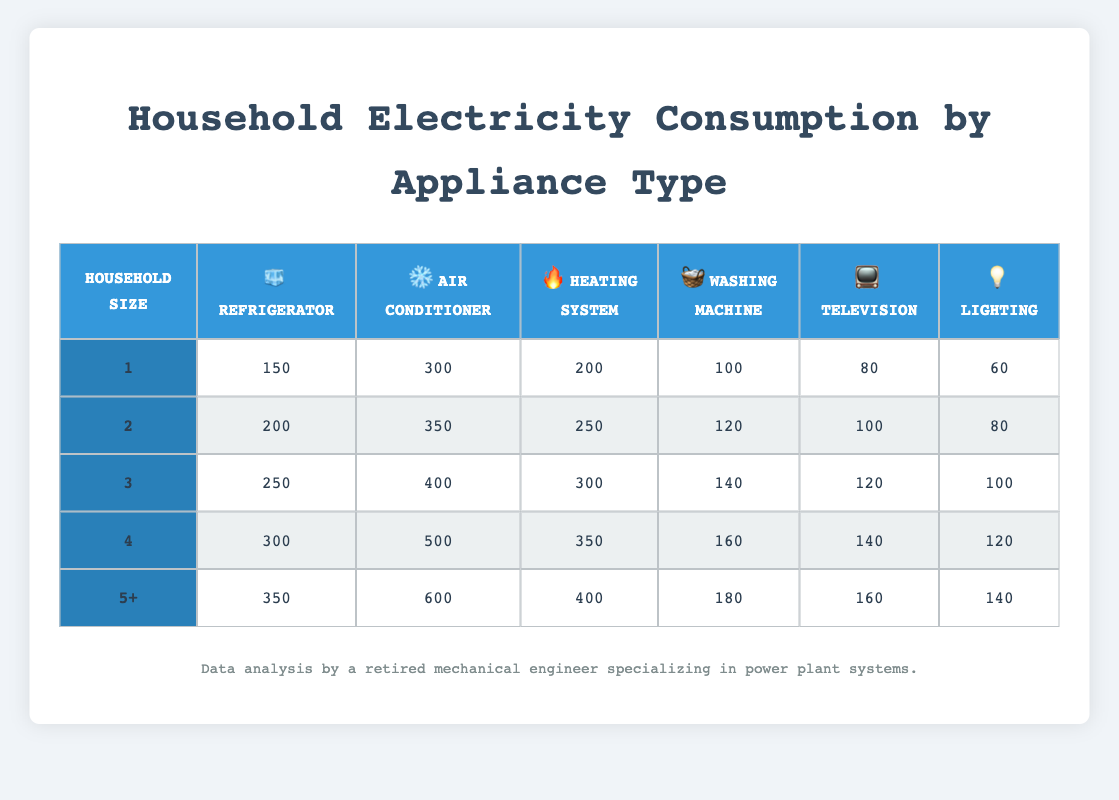What is the electricity consumption of a refrigerator for a household size of 3? In the table, locate the row for Household Size 3, which corresponds to its respective appliances. Under the Refrigerator column for Household Size 3, the consumption is 250.
Answer: 250 What is the highest electricity consumption for the air conditioner across all household sizes? Review all the entries in the Air Conditioner column. The highest value is found under the 5+ Household Size, which is 600.
Answer: 600 Is the electricity consumption of a heating system higher for a household size of 2 than for a household size of 1? Compare the Heating System values for Household Sizes 1 and 2: Household Size 1 consumes 200, and Household Size 2 consumes 250. Since 250 is greater than 200, the statement is true.
Answer: Yes What is the average electricity consumption of televisions across all household sizes? To find the average, first sum the total electricity consumption from the Television column: 80 + 100 + 120 + 140 + 160 = 600. Then, divide by the number of household sizes, which is 5. Thus, the average is calculated as 600/5 = 120.
Answer: 120 For a household of size 4, how much more electricity does the air conditioning consume compared to the lighting? Check the values for Household Size 4: Air Conditioner is 500, and Lighting is 120. Calculate the difference: 500 - 120 = 380.
Answer: 380 What is the electricity consumption of a washing machine in a household size of 5+? Look for the Washing Machine column corresponding to Household Size 5+, where the value is 180.
Answer: 180 Is it true that larger households consistently consume more electricity for all appliances compared to smaller households? To determine this, compare the values of each appliance across all household sizes. For each appliance, the data shows that as household size increases, the consumption values also rise. Hence, the statement is true.
Answer: Yes How much total electricity does a household of size 3 consume for long-term appliances (refrigerator and air conditioner)? Locate the values for Household Size 3: Refrigerator uses 250 and Air Conditioner uses 400. Add them together: 250 + 400 = 650.
Answer: 650 What is the difference in electricity consumption between a washing machine for a household size of 4 and a household size of 2? Compare the Washing Machine values for Household Sizes 4 and 2: Household Size 4 uses 160, and Household Size 2 uses 120. Compute the difference: 160 - 120 = 40.
Answer: 40 